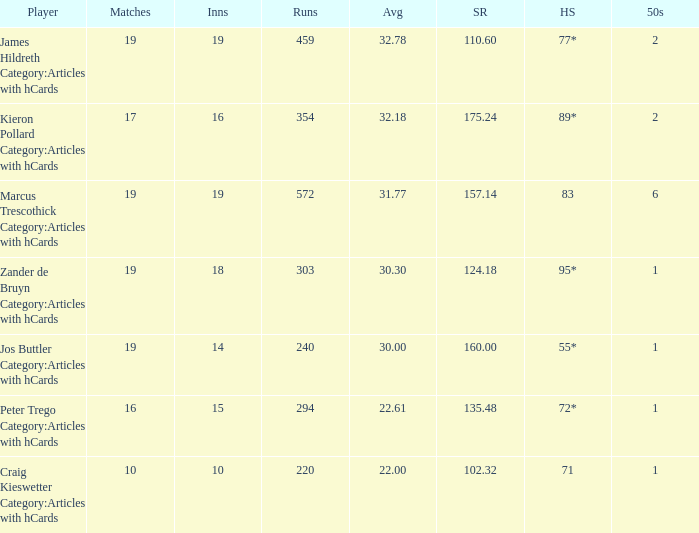Can you parse all the data within this table? {'header': ['Player', 'Matches', 'Inns', 'Runs', 'Avg', 'SR', 'HS', '50s'], 'rows': [['James Hildreth Category:Articles with hCards', '19', '19', '459', '32.78', '110.60', '77*', '2'], ['Kieron Pollard Category:Articles with hCards', '17', '16', '354', '32.18', '175.24', '89*', '2'], ['Marcus Trescothick Category:Articles with hCards', '19', '19', '572', '31.77', '157.14', '83', '6'], ['Zander de Bruyn Category:Articles with hCards', '19', '18', '303', '30.30', '124.18', '95*', '1'], ['Jos Buttler Category:Articles with hCards', '19', '14', '240', '30.00', '160.00', '55*', '1'], ['Peter Trego Category:Articles with hCards', '16', '15', '294', '22.61', '135.48', '72*', '1'], ['Craig Kieswetter Category:Articles with hCards', '10', '10', '220', '22.00', '102.32', '71', '1']]} What is the strike rate for the player with an average of 32.78? 110.6. 